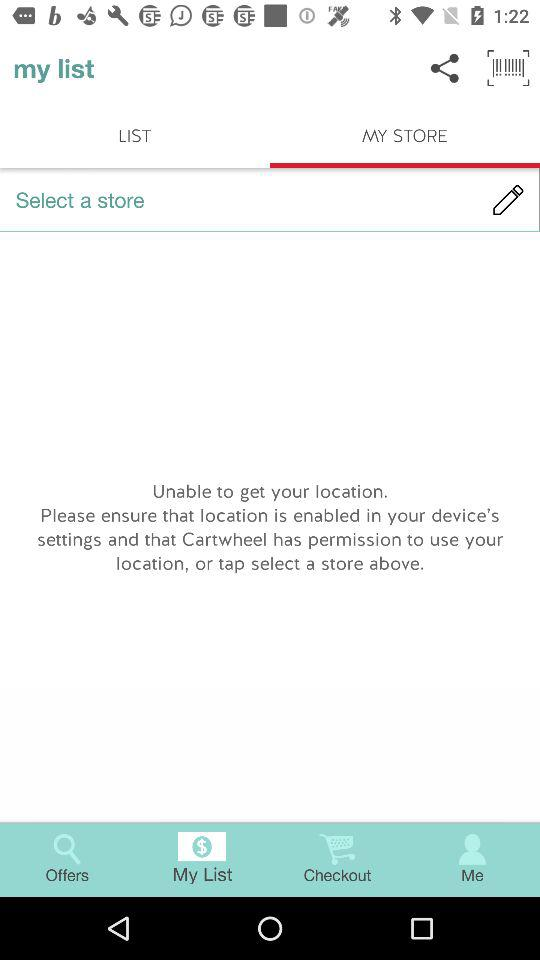Which tab is selected? The selected tabs are "My List" and "MY STORE". 